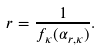<formula> <loc_0><loc_0><loc_500><loc_500>r = \frac { 1 } { f _ { \kappa } ( \alpha _ { r , \kappa } ) } .</formula> 